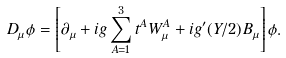Convert formula to latex. <formula><loc_0><loc_0><loc_500><loc_500>D _ { \mu } \phi = \left [ \partial _ { \mu } + i g \sum ^ { 3 } _ { A = 1 } t ^ { A } W ^ { A } _ { \mu } + i g ^ { \prime } ( Y / 2 ) B _ { \mu } \right ] \phi .</formula> 